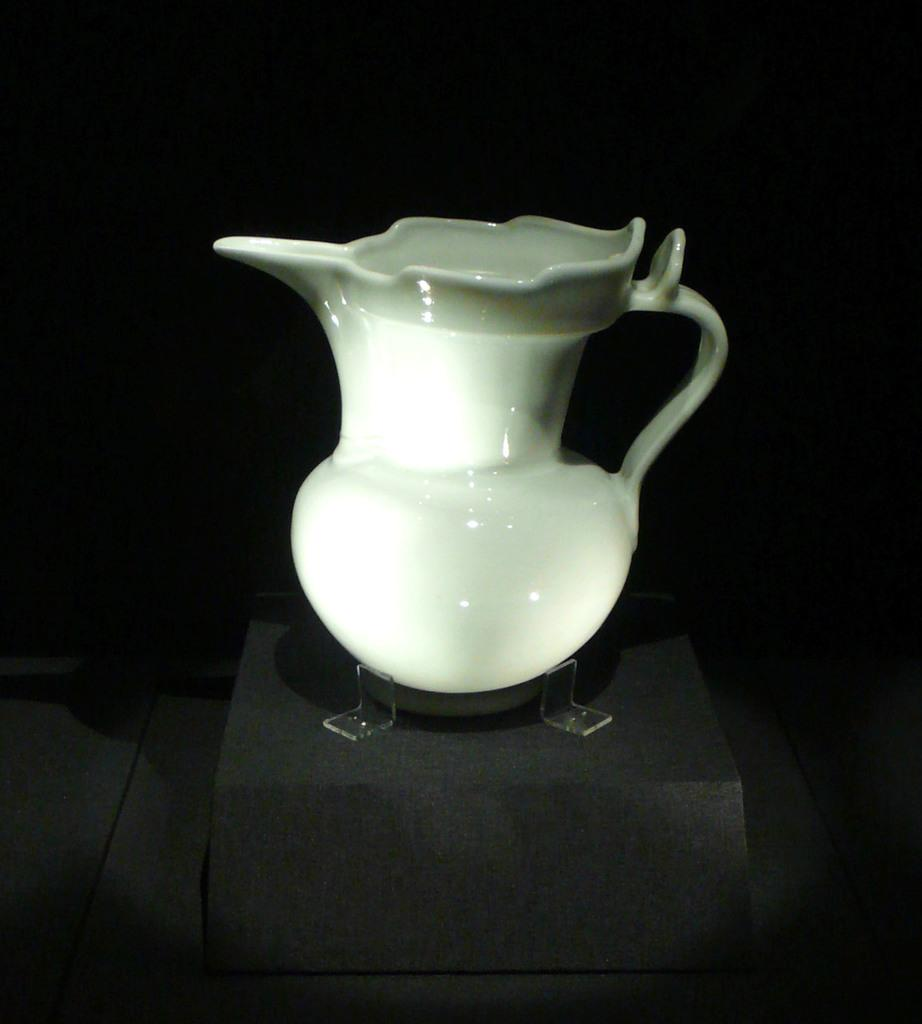What is the main object in the image? There is a jug in the image. What is the jug placed on? The jug is placed on an object. Can you describe the background of the image? The background of the image is dark. How does the crowd help the jug in the image? There is no crowd present in the image, so it cannot help the jug. 